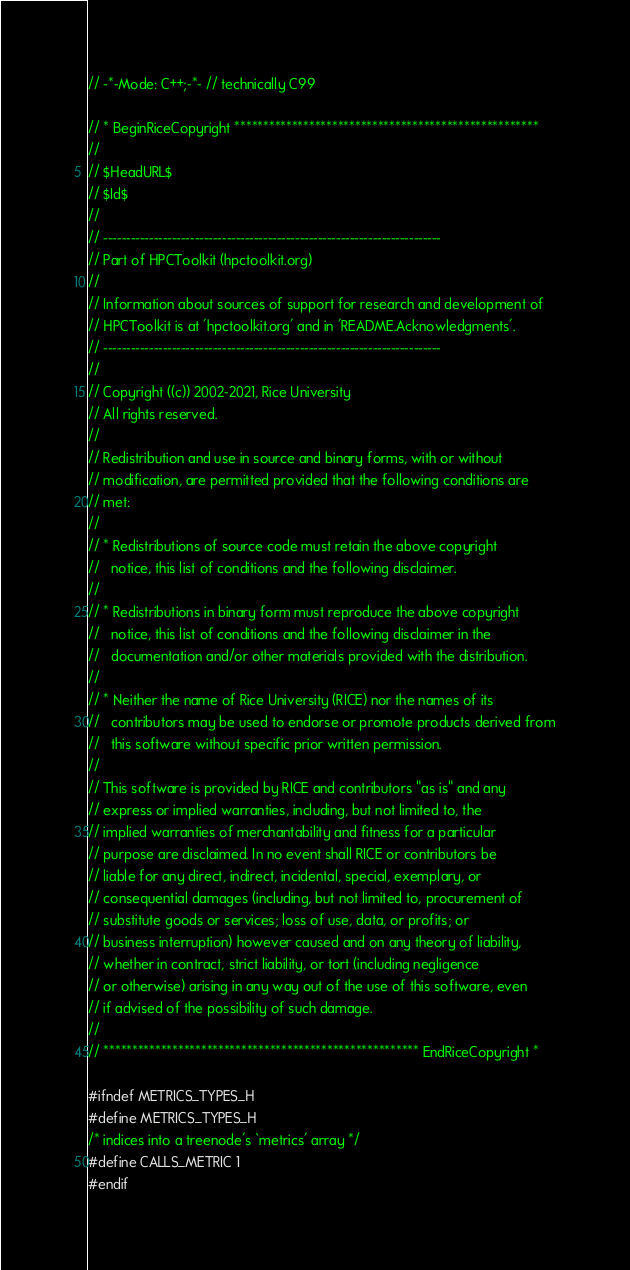<code> <loc_0><loc_0><loc_500><loc_500><_C_>// -*-Mode: C++;-*- // technically C99

// * BeginRiceCopyright *****************************************************
//
// $HeadURL$
// $Id$
//
// --------------------------------------------------------------------------
// Part of HPCToolkit (hpctoolkit.org)
//
// Information about sources of support for research and development of
// HPCToolkit is at 'hpctoolkit.org' and in 'README.Acknowledgments'.
// --------------------------------------------------------------------------
//
// Copyright ((c)) 2002-2021, Rice University
// All rights reserved.
//
// Redistribution and use in source and binary forms, with or without
// modification, are permitted provided that the following conditions are
// met:
//
// * Redistributions of source code must retain the above copyright
//   notice, this list of conditions and the following disclaimer.
//
// * Redistributions in binary form must reproduce the above copyright
//   notice, this list of conditions and the following disclaimer in the
//   documentation and/or other materials provided with the distribution.
//
// * Neither the name of Rice University (RICE) nor the names of its
//   contributors may be used to endorse or promote products derived from
//   this software without specific prior written permission.
//
// This software is provided by RICE and contributors "as is" and any
// express or implied warranties, including, but not limited to, the
// implied warranties of merchantability and fitness for a particular
// purpose are disclaimed. In no event shall RICE or contributors be
// liable for any direct, indirect, incidental, special, exemplary, or
// consequential damages (including, but not limited to, procurement of
// substitute goods or services; loss of use, data, or profits; or
// business interruption) however caused and on any theory of liability,
// whether in contract, strict liability, or tort (including negligence
// or otherwise) arising in any way out of the use of this software, even
// if advised of the possibility of such damage.
//
// ******************************************************* EndRiceCopyright *

#ifndef METRICS_TYPES_H
#define METRICS_TYPES_H
/* indices into a treenode's `metrics' array */
#define CALLS_METRIC 1
#endif
</code> 